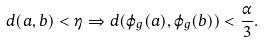<formula> <loc_0><loc_0><loc_500><loc_500>d ( a , b ) < \eta \Rightarrow d ( \varphi _ { g } ( a ) , \varphi _ { g } ( b ) ) < \frac { \alpha } { 3 } .</formula> 